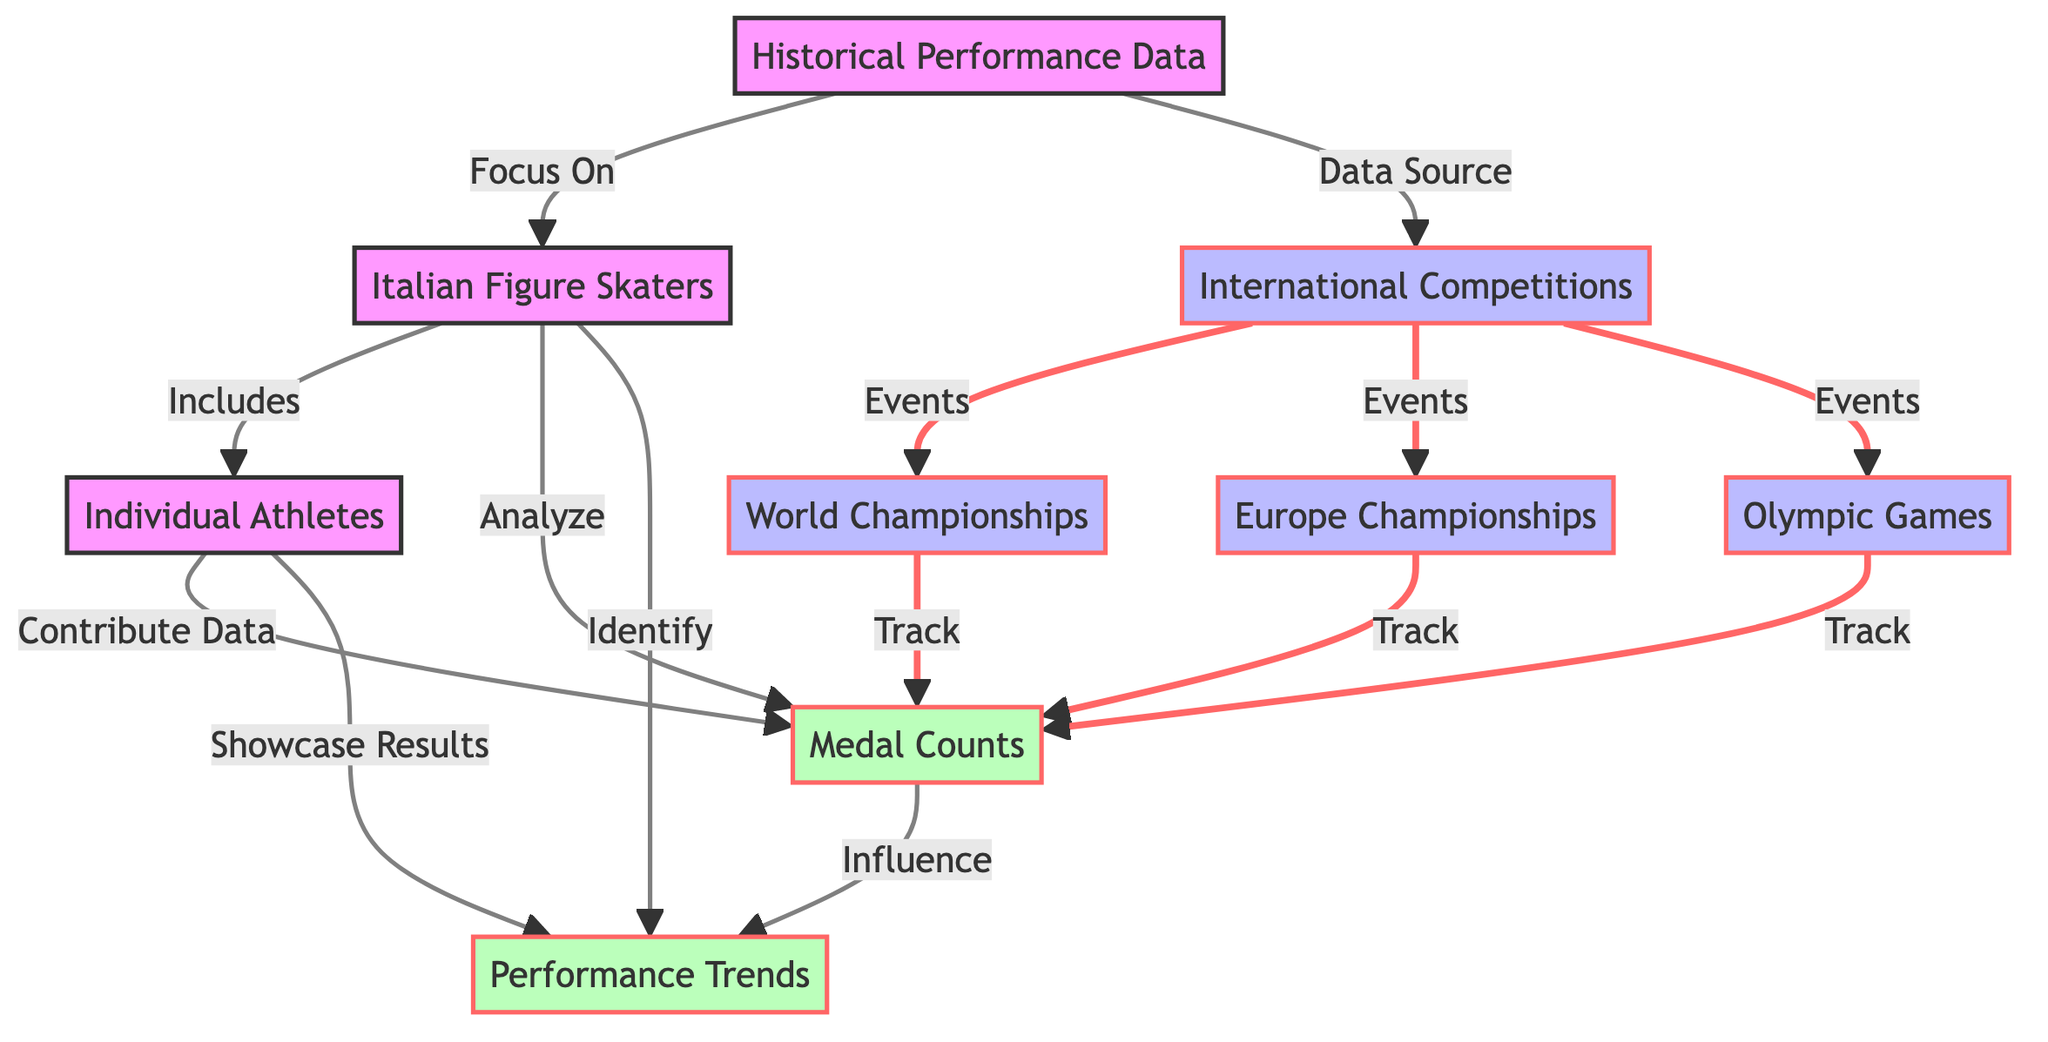What are the main categories of data in the diagram? The diagram is structured around three main categories: Historical Performance Data, Italian Figure Skaters, and International Competitions. Each category encompasses specific nodes that provide detailed information.
Answer: Historical Performance Data, Italian Figure Skaters, International Competitions Which competitions are included under International Competitions? The diagram specifies three types of international competitions: World Championships, Europe Championships, and Olympic Games, which are all connected to the International Competitions node.
Answer: World Championships, Europe Championships, Olympic Games How many types of data analysis are performed regarding Italian Figure Skaters? The diagram indicates that there are two main analyses related to Italian Figure Skaters: analyzing Medal Counts and identifying Performance Trends.
Answer: Two What influences Performance Trends according to the diagram? The diagram shows that Medal Counts influence Performance Trends, indicating a relationship where the success of the skaters, measured by medals, impacts the trends observed over time.
Answer: Medal Counts What is the relationship between Individual Athletes and Medal Counts? Individual Athletes contribute data to Medal Counts, which means that the performance of each athlete plays a vital role in determining the overall medal count.
Answer: Contribute Data Which competitions specifically track Medal Counts? The diagram indicates that Medal Counts are tracked by World Championships, Europe Championships, and Olympic Games, showing the relationship between these competitions and medal tracking.
Answer: World Championships, Europe Championships, Olympic Games How are Performance Trends showcased according to the diagram? The diagram demonstrates that Performance Trends are showcased through results, meaning that insights and patterns derived from medal statistics reflect the performance levels of skaters over time.
Answer: Showcase Results What connects Individual Athletes to Performance Trends in the diagram? The diagram indicates that Individual Athletes showcase results, which connects their individual performances to overall Performance Trends in Italian figure skating.
Answer: Showcase Results 